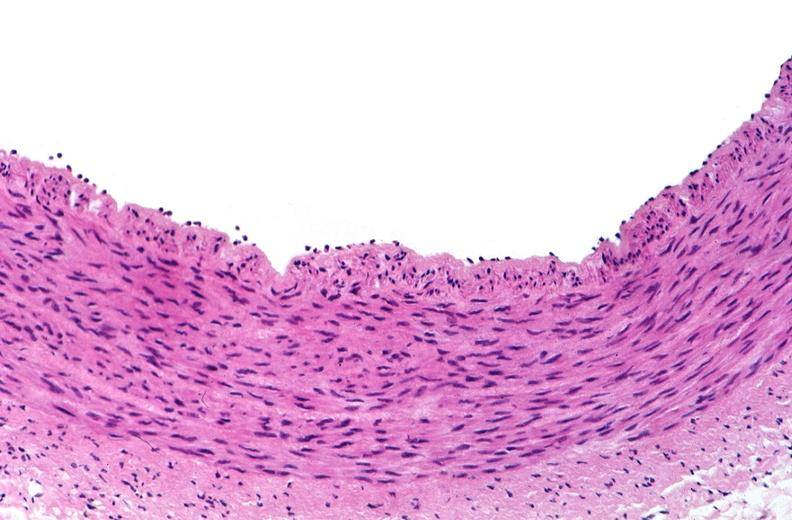s intraductal papillomatosis present?
Answer the question using a single word or phrase. No 